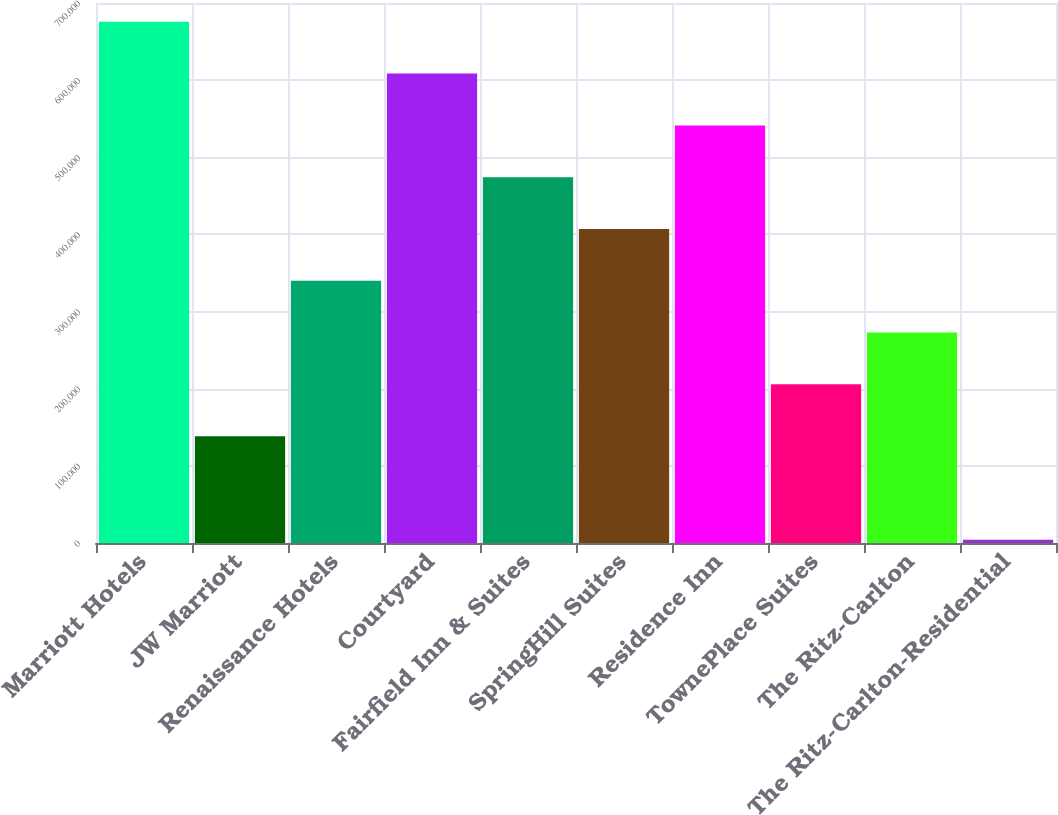Convert chart to OTSL. <chart><loc_0><loc_0><loc_500><loc_500><bar_chart><fcel>Marriott Hotels<fcel>JW Marriott<fcel>Renaissance Hotels<fcel>Courtyard<fcel>Fairfield Inn & Suites<fcel>SpringHill Suites<fcel>Residence Inn<fcel>TownePlace Suites<fcel>The Ritz-Carlton<fcel>The Ritz-Carlton-Residential<nl><fcel>675623<fcel>138507<fcel>339926<fcel>608484<fcel>474204<fcel>407065<fcel>541344<fcel>205646<fcel>272786<fcel>4228<nl></chart> 